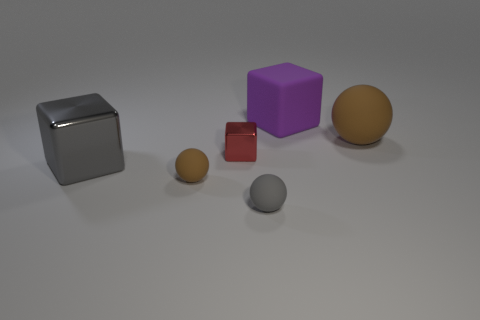What shape is the large rubber object to the left of the brown matte sphere on the right side of the red object?
Keep it short and to the point. Cube. What shape is the brown matte thing in front of the big object in front of the large matte object that is right of the purple thing?
Your answer should be very brief. Sphere. How many other gray objects are the same shape as the gray rubber thing?
Your response must be concise. 0. There is a large block behind the small block; how many large spheres are on the left side of it?
Provide a short and direct response. 0. What number of rubber things are small cubes or gray cubes?
Provide a short and direct response. 0. Is there a red cube that has the same material as the purple object?
Provide a succinct answer. No. How many things are either purple things that are right of the gray rubber thing or large brown matte spheres that are behind the big gray object?
Offer a terse response. 2. There is a small rubber thing right of the tiny brown matte thing; does it have the same color as the large metal object?
Make the answer very short. Yes. What number of other things are there of the same color as the rubber cube?
Keep it short and to the point. 0. What material is the red cube?
Offer a terse response. Metal. 